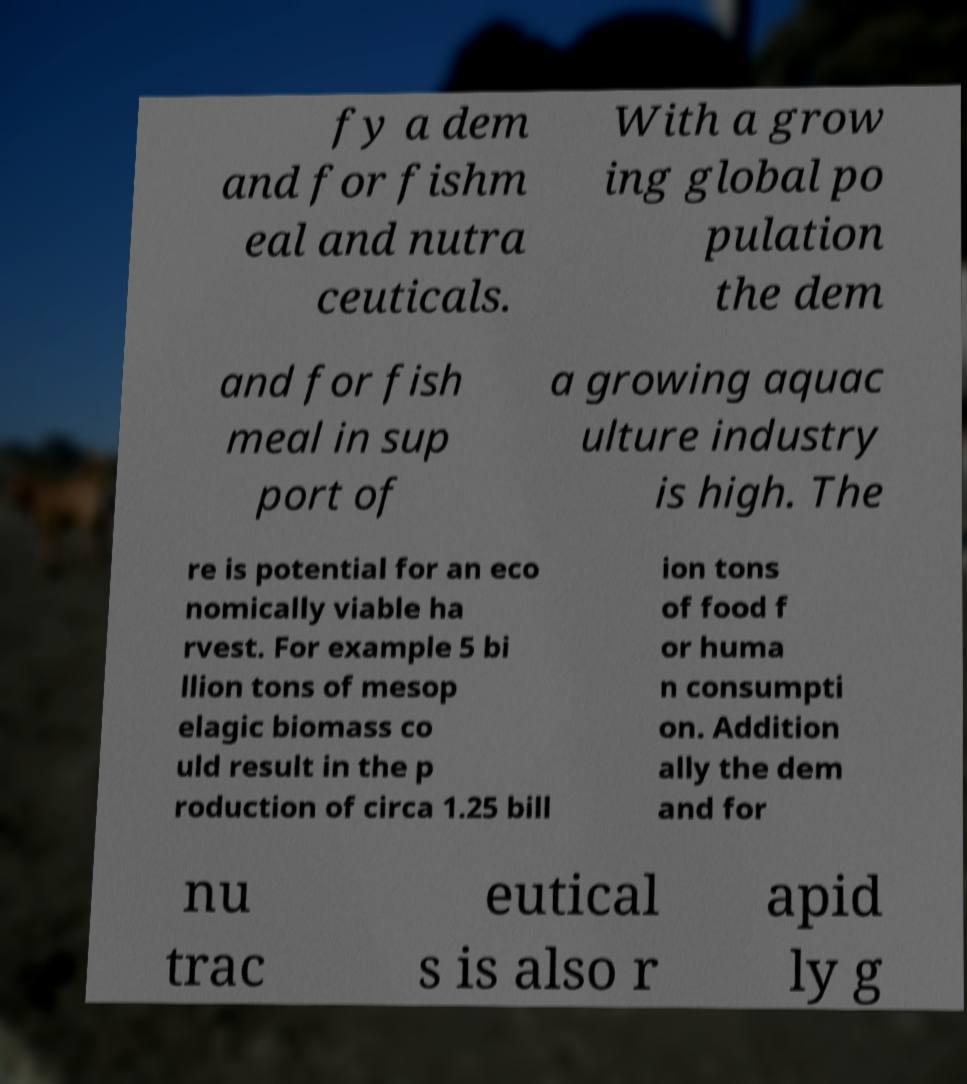For documentation purposes, I need the text within this image transcribed. Could you provide that? fy a dem and for fishm eal and nutra ceuticals. With a grow ing global po pulation the dem and for fish meal in sup port of a growing aquac ulture industry is high. The re is potential for an eco nomically viable ha rvest. For example 5 bi llion tons of mesop elagic biomass co uld result in the p roduction of circa 1.25 bill ion tons of food f or huma n consumpti on. Addition ally the dem and for nu trac eutical s is also r apid ly g 